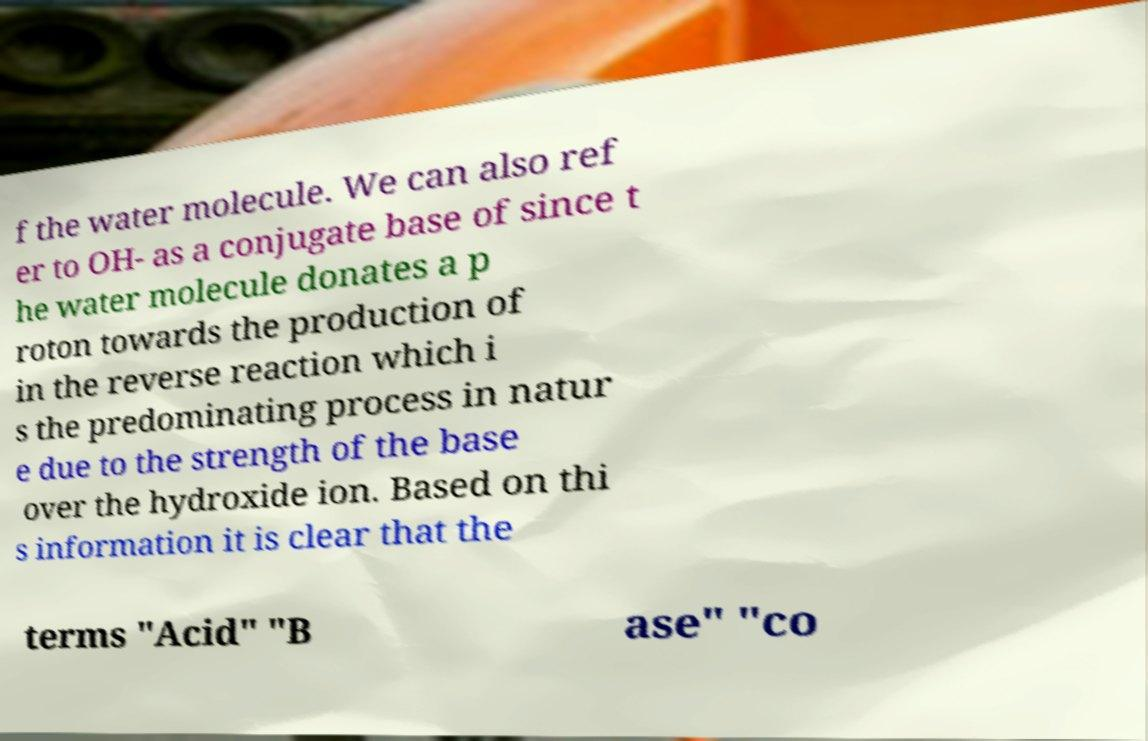Could you extract and type out the text from this image? f the water molecule. We can also ref er to OH- as a conjugate base of since t he water molecule donates a p roton towards the production of in the reverse reaction which i s the predominating process in natur e due to the strength of the base over the hydroxide ion. Based on thi s information it is clear that the terms "Acid" "B ase" "co 